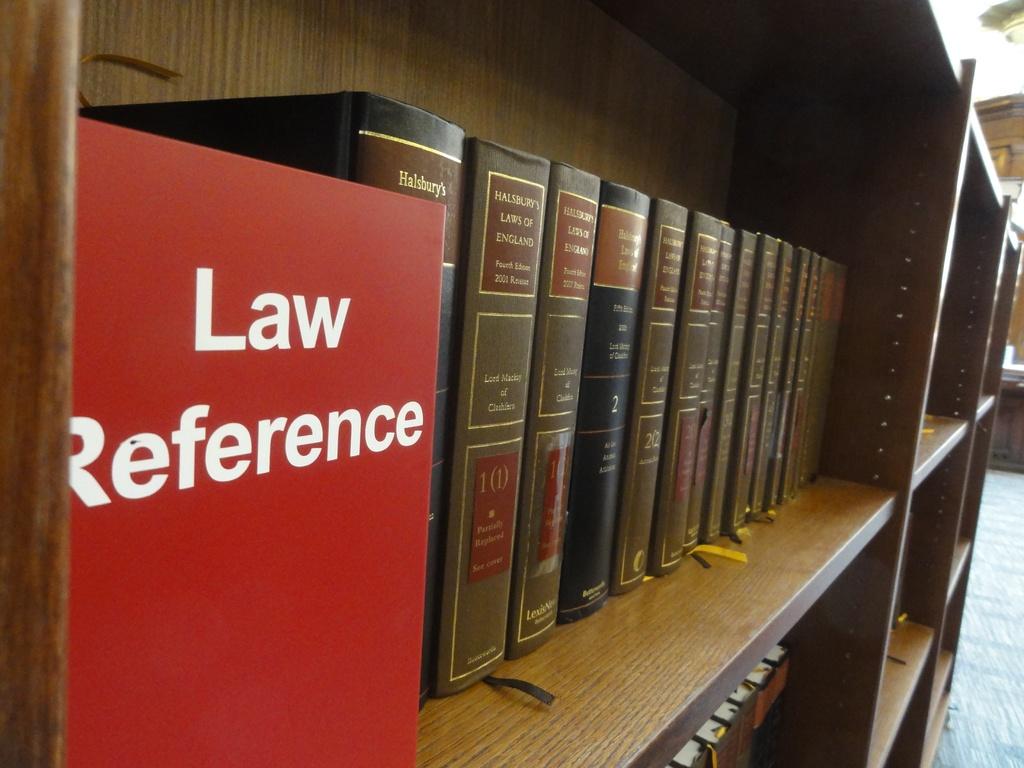What type of reference?
Ensure brevity in your answer.  Law. Is this a legal library?
Your answer should be very brief. Yes. 